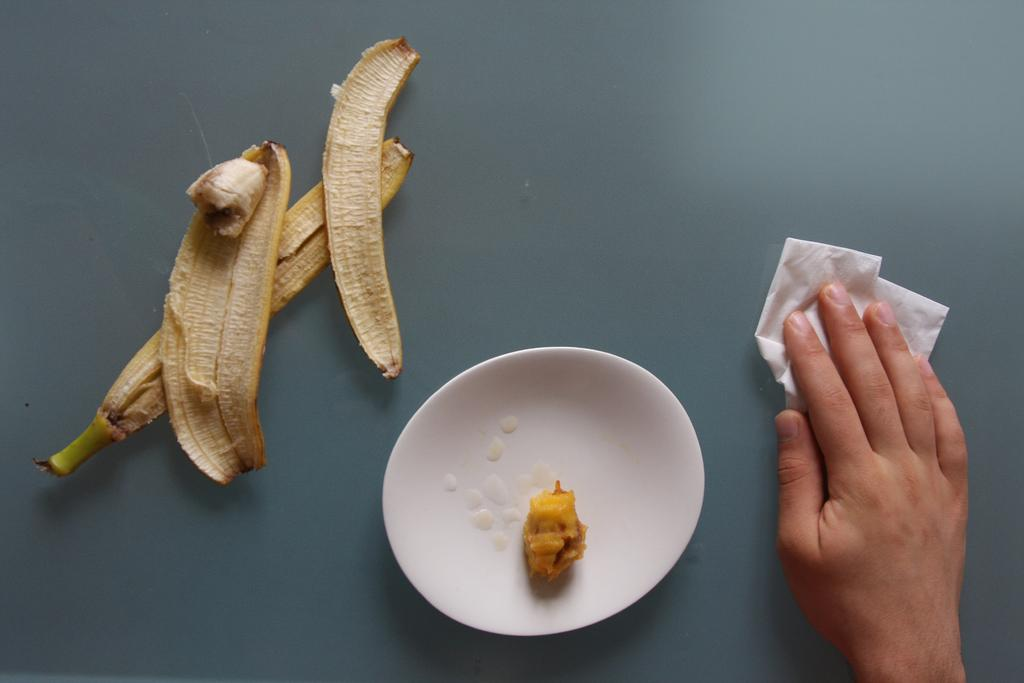What is present in the image that people typically use for eating or serving food? There is a table in the image. What is the person doing in the image? The person is cleaning the table with a napkin. What evidence is there that the person has eaten food? There are banana peels visible in the image. What else can be seen on the table besides the banana peels? There is a plate containing food in the image. What type of dust can be seen on the seashore in the image? There is no seashore or dust present in the image; it features a table with a person cleaning it. 